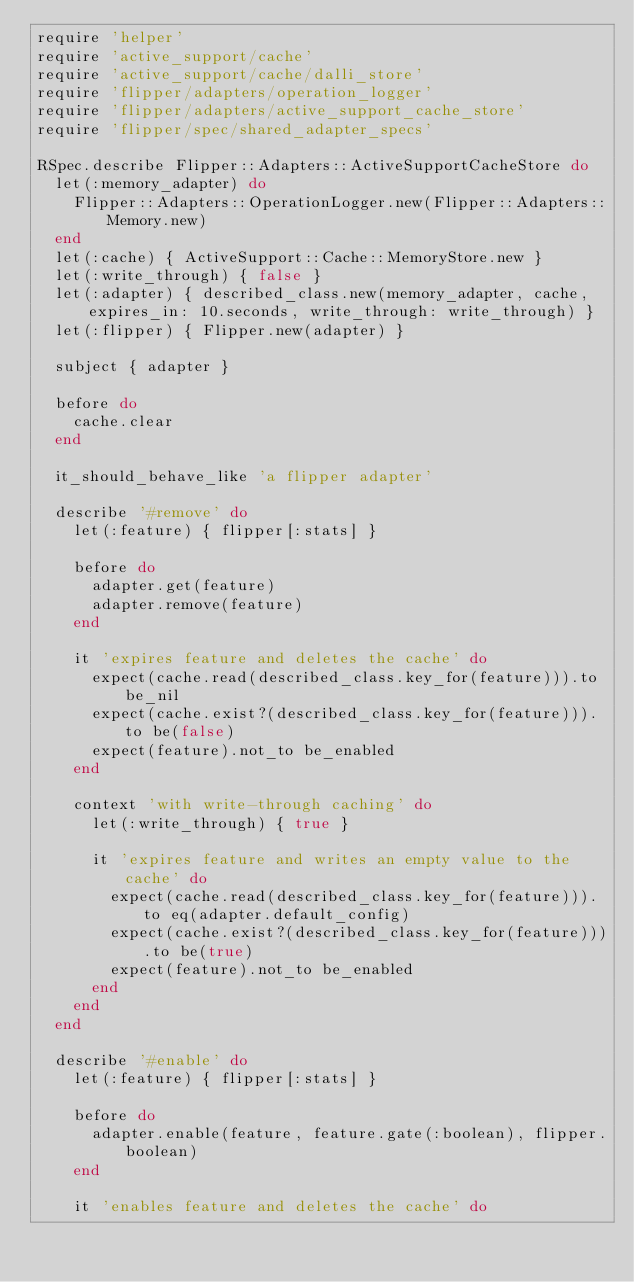<code> <loc_0><loc_0><loc_500><loc_500><_Ruby_>require 'helper'
require 'active_support/cache'
require 'active_support/cache/dalli_store'
require 'flipper/adapters/operation_logger'
require 'flipper/adapters/active_support_cache_store'
require 'flipper/spec/shared_adapter_specs'

RSpec.describe Flipper::Adapters::ActiveSupportCacheStore do
  let(:memory_adapter) do
    Flipper::Adapters::OperationLogger.new(Flipper::Adapters::Memory.new)
  end
  let(:cache) { ActiveSupport::Cache::MemoryStore.new }
  let(:write_through) { false }
  let(:adapter) { described_class.new(memory_adapter, cache, expires_in: 10.seconds, write_through: write_through) }
  let(:flipper) { Flipper.new(adapter) }

  subject { adapter }

  before do
    cache.clear
  end

  it_should_behave_like 'a flipper adapter'

  describe '#remove' do
    let(:feature) { flipper[:stats] }

    before do
      adapter.get(feature)
      adapter.remove(feature)
    end

    it 'expires feature and deletes the cache' do
      expect(cache.read(described_class.key_for(feature))).to be_nil
      expect(cache.exist?(described_class.key_for(feature))).to be(false)
      expect(feature).not_to be_enabled
    end

    context 'with write-through caching' do
      let(:write_through) { true }

      it 'expires feature and writes an empty value to the cache' do
        expect(cache.read(described_class.key_for(feature))).to eq(adapter.default_config)
        expect(cache.exist?(described_class.key_for(feature))).to be(true)
        expect(feature).not_to be_enabled
      end
    end
  end

  describe '#enable' do
    let(:feature) { flipper[:stats] }

    before do
      adapter.enable(feature, feature.gate(:boolean), flipper.boolean)
    end

    it 'enables feature and deletes the cache' do</code> 